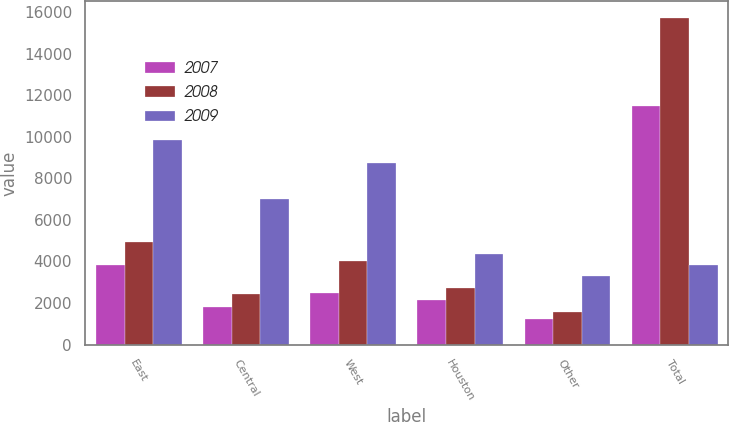Convert chart. <chart><loc_0><loc_0><loc_500><loc_500><stacked_bar_chart><ecel><fcel>East<fcel>Central<fcel>West<fcel>Houston<fcel>Other<fcel>Total<nl><fcel>2007<fcel>3817<fcel>1796<fcel>2480<fcel>2150<fcel>1235<fcel>11478<nl><fcel>2008<fcel>4957<fcel>2442<fcel>4031<fcel>2736<fcel>1569<fcel>15735<nl><fcel>2009<fcel>9840<fcel>7020<fcel>8739<fcel>4380<fcel>3304<fcel>3817<nl></chart> 